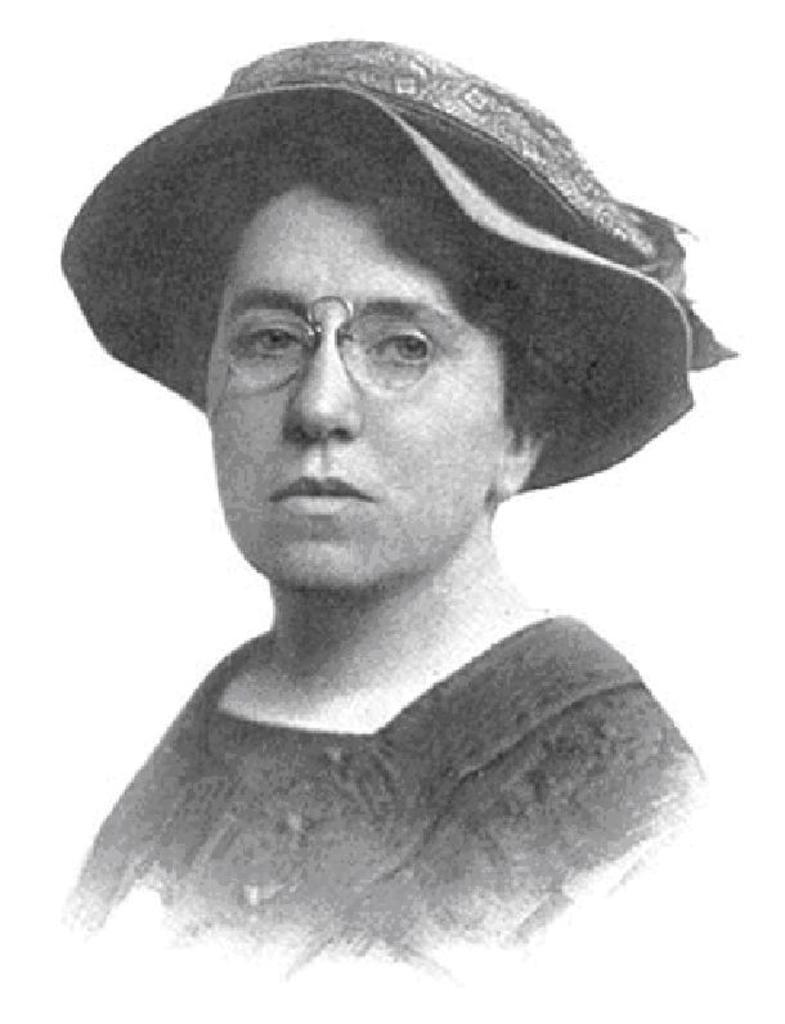What type of picture is in the image? The image contains a black and white picture. What is the subject of the picture? The picture depicts a woman. What color is the kitten playing with the brass object in the image? There is no kitten or brass object present in the image; it only contains a black and white picture of a woman. 